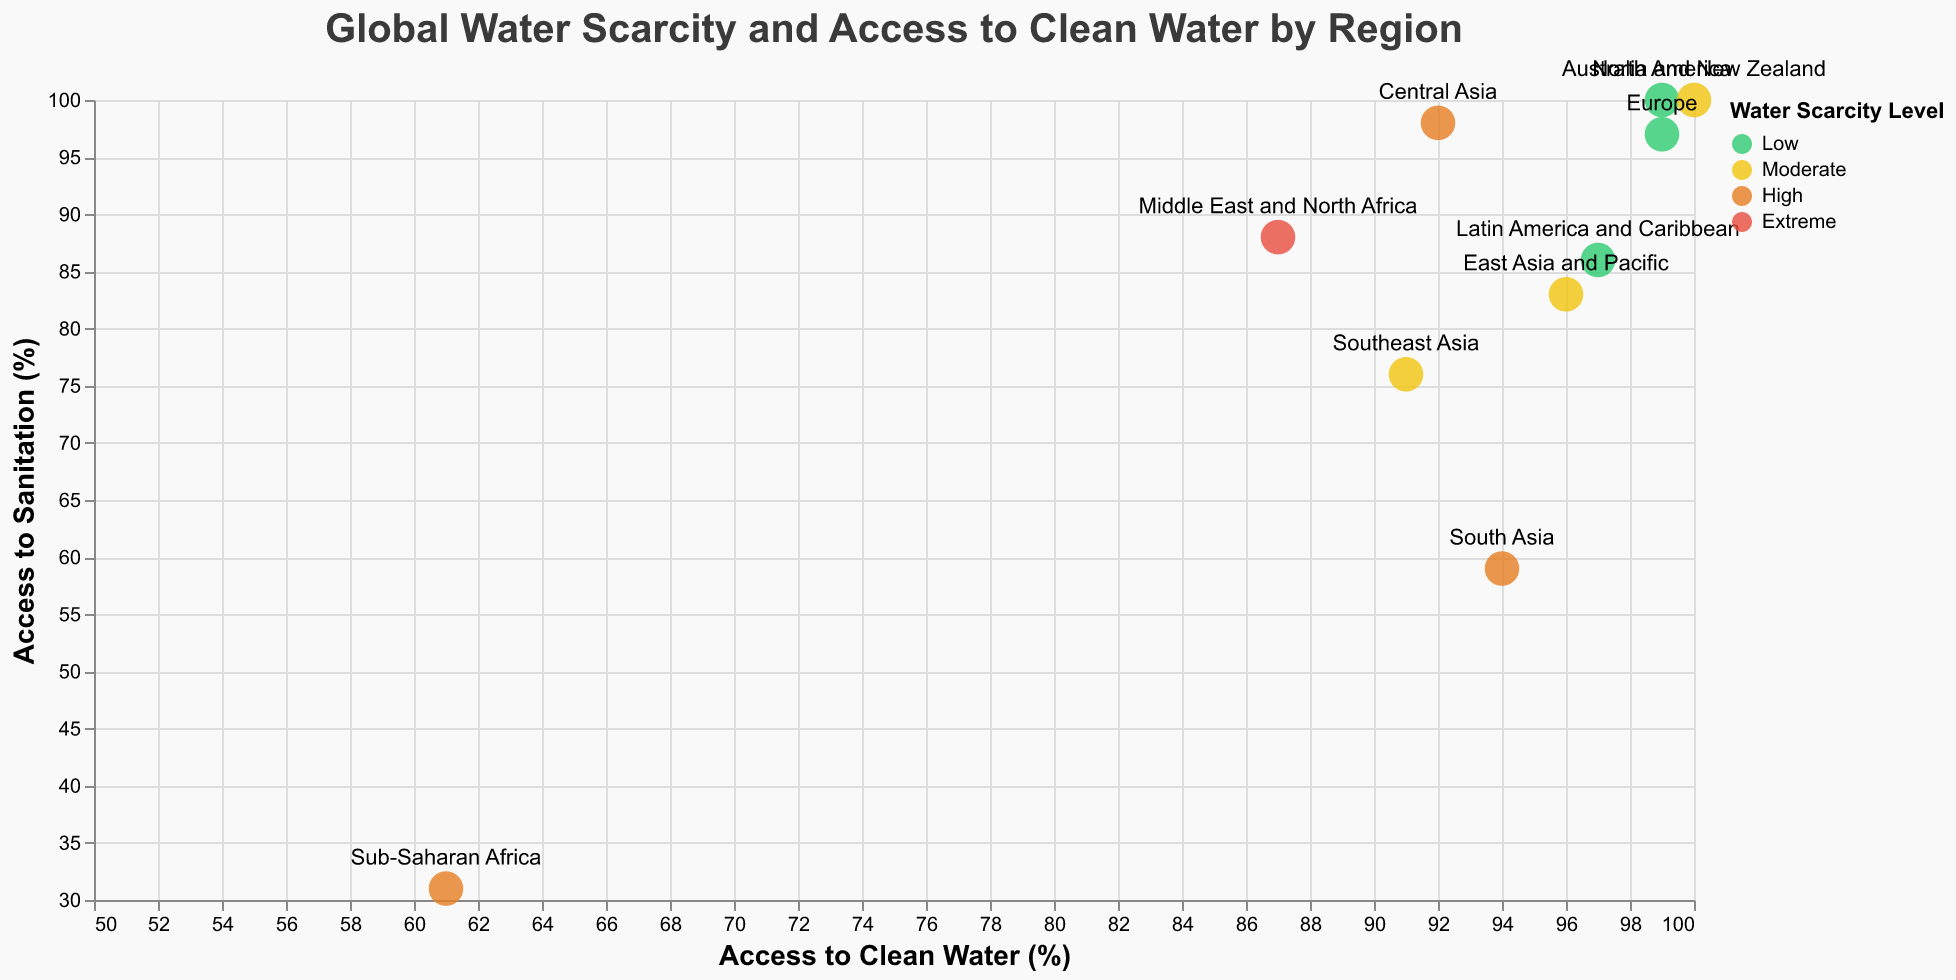Which region has the highest access to clean drinking water? Look for the highest value on the x-axis (Access to Clean Water %). Both North America and Australia and New Zealand have 100%.
Answer: North America, Australia and New Zealand Which regions experience 'High' water scarcity levels? Identify regions with the color corresponding to 'High' water scarcity, which is orange in the plot's legend. These regions are Sub-Saharan Africa, South Asia, and Central Asia.
Answer: Sub-Saharan Africa, South Asia, Central Asia How does access to sanitation in Sub-Saharan Africa compare to that in Europe? Find Sub-Saharan Africa and Europe on the y-axis (Access to Sanitation %). Sub-Saharan Africa has 31%, while Europe has 97%.
Answer: Sub-Saharan Africa: 31%, Europe: 97% What is the relation between water scarcity levels and access to sanitation in the Middle East and North Africa? Locate Middle East and North Africa on the plot, which has 'Extreme' water scarcity (red color). The data point shows it has 88% access to sanitation.
Answer: Extreme scarcity, 88% sanitation Is there a correlation between high access to clean water and low water scarcity? Generally, check if regions with higher access to clean water (% closer to 100) have 'Low' water scarcity levels (green color). North America and Europe show this pattern.
Answer: Yes Which region has the lowest access to sanitation? Look for the lowest value on the y-axis (Access to Sanitation %). Sub-Saharan Africa has the lowest at 31%.
Answer: Sub-Saharan Africa How many regions have both more than 90% access to clean water and more than 80% access to sanitation? Identify data points with x (Access to Clean Water %) > 90 and y (Access to Sanitation %) > 80. These regions are East Asia and Pacific, Latin America and Caribbean, North America, Europe, Central Asia, and Australia and New Zealand.
Answer: 6 regions Which region has the most extreme water scarcity level, and what is its access to clean water? Check for the region with 'Extreme' water scarcity (red color). The Middle East and North Africa has 'Extreme' water scarcity and 87% access to clean water.
Answer: Middle East and North Africa, 87% Which region in Southeast Asia has a 'Moderate' level of water scarcity, and what are its access rates for clean water and sanitation? Identify Southeast Asia which has 'Moderate' water scarcity (yellow color). The data shows it has 91% access to clean water and 76% access to sanitation.
Answer: Southeast Asia, 91% clean water, 76% sanitation 